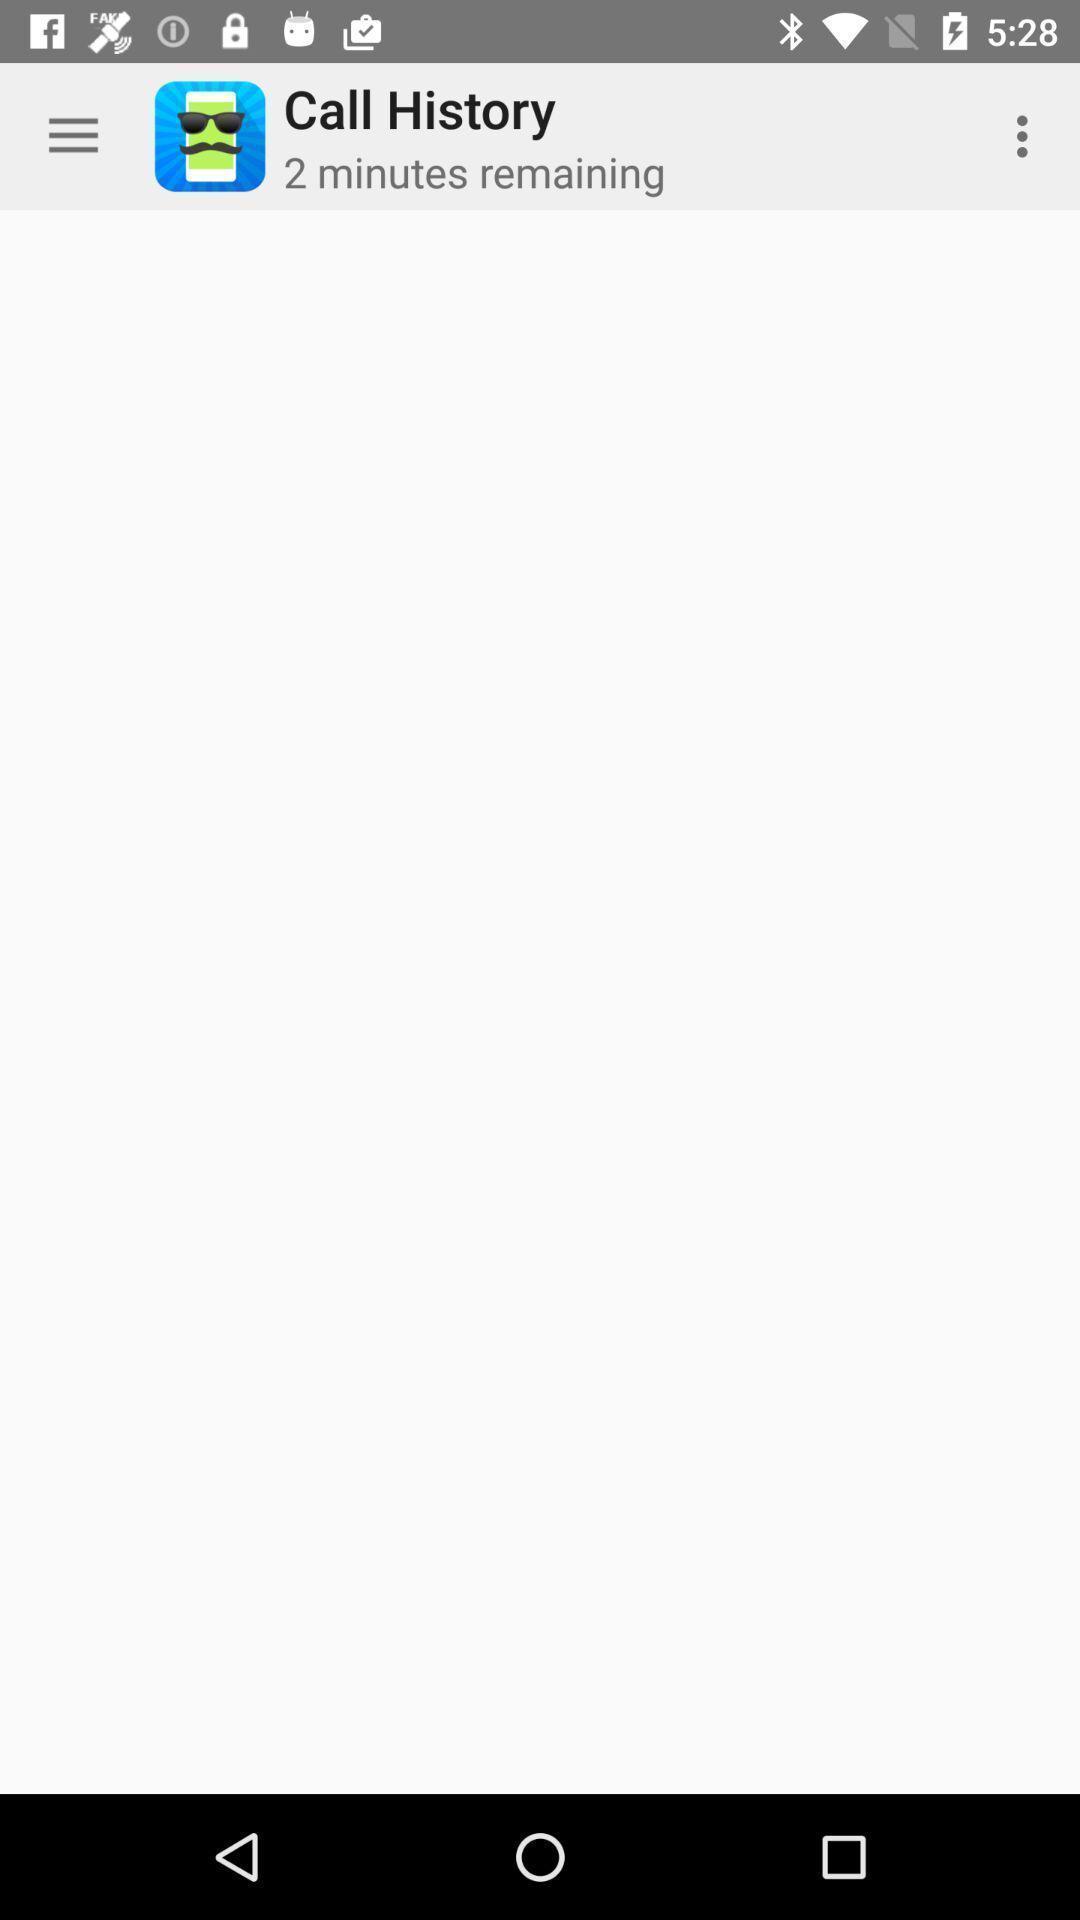Summarize the main components in this picture. Page displaying the history of call. 